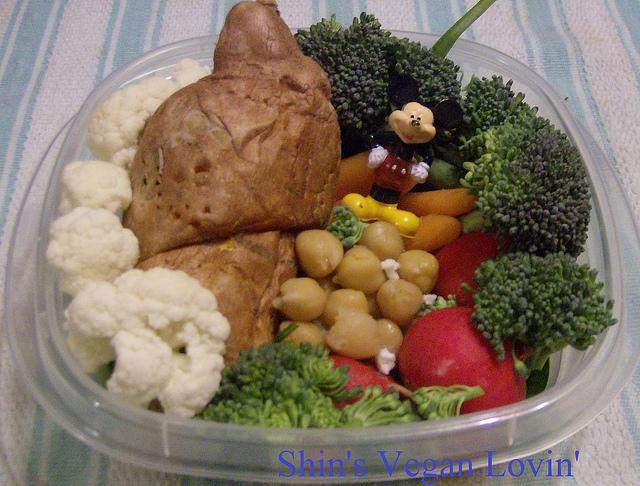Is this cooked?
Give a very brief answer. No. How many beans are in the dish?
Concise answer only. 10. Do you see a toy?
Quick response, please. Yes. 